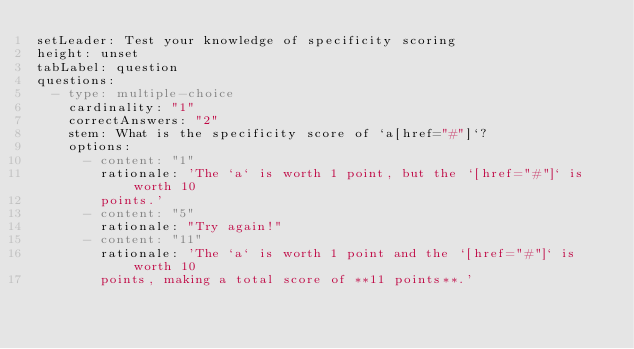Convert code to text. <code><loc_0><loc_0><loc_500><loc_500><_YAML_>setLeader: Test your knowledge of specificity scoring
height: unset
tabLabel: question
questions:
  - type: multiple-choice
    cardinality: "1"
    correctAnswers: "2"
    stem: What is the specificity score of `a[href="#"]`?
    options:
      - content: "1"
        rationale: 'The `a` is worth 1 point, but the `[href="#"]` is worth 10
        points.'
      - content: "5"
        rationale: "Try again!"
      - content: "11"
        rationale: 'The `a` is worth 1 point and the `[href="#"]` is worth 10
        points, making a total score of **11 points**.'
</code> 